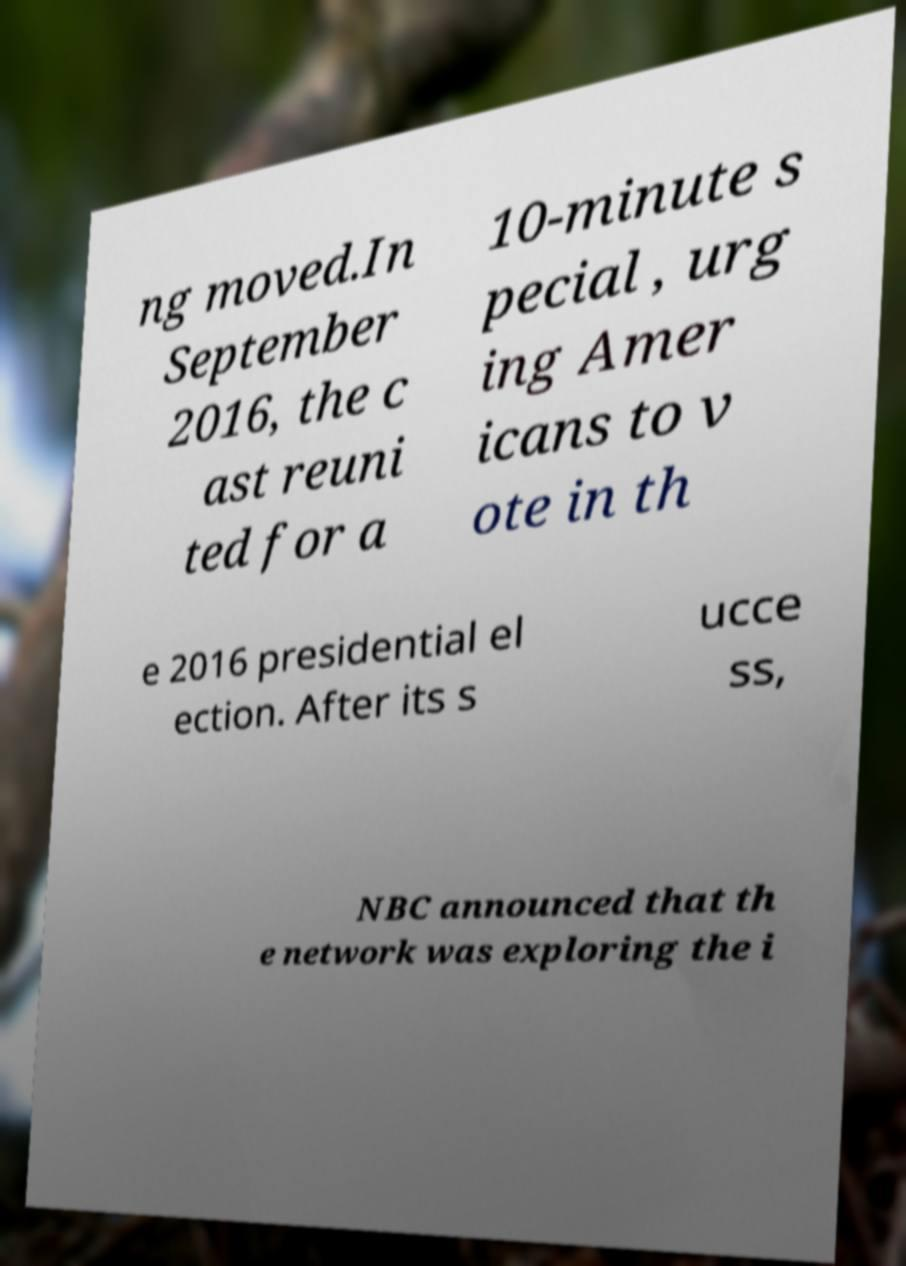Can you read and provide the text displayed in the image?This photo seems to have some interesting text. Can you extract and type it out for me? ng moved.In September 2016, the c ast reuni ted for a 10-minute s pecial , urg ing Amer icans to v ote in th e 2016 presidential el ection. After its s ucce ss, NBC announced that th e network was exploring the i 